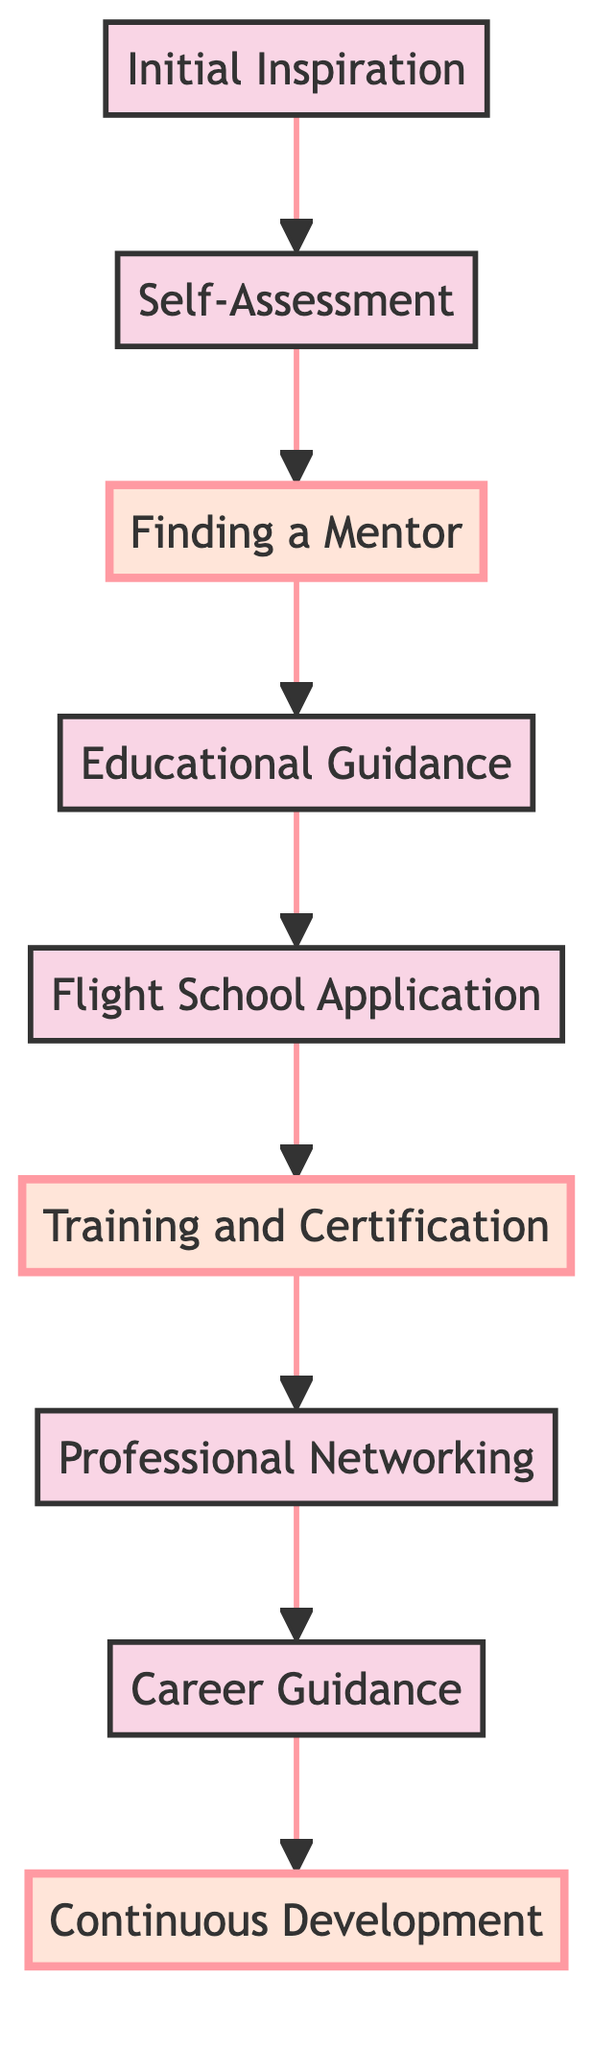What's the first step in the mentorship pathway? The diagram indicates that the first step is "Initial Inspiration," which represents the exposure to pioneering female pilots.
Answer: Initial Inspiration How many nodes are in the diagram? By counting each distinct step as represented in the diagram, there are a total of nine nodes representing various parts of the mentorship pathway.
Answer: 9 What comes after "Finding a Mentor"? Following the node "Finding a Mentor," the next step in the flow is "Educational Guidance," which suggests the move towards receiving advice on suitable aviation programs.
Answer: Educational Guidance Which step focuses on networking within the aviation industry? The diagram identifies "Professional Networking" as the step specifically aimed at building connections within the aviation industry.
Answer: Professional Networking What is the last step in the mentorship pathway? The terminal step in the diagram is "Continuous Development," which reflects the ongoing learning and specialization to enhance skills as a pilot.
Answer: Continuous Development Which two steps are highlighted in the diagram? The highlighted steps are "Finding a Mentor" and "Training and Certification," indicating their importance in the mentorship pathway.
Answer: Finding a Mentor, Training and Certification What does "Career Guidance" entail according to the diagram? The node "Career Guidance" suggests it involves navigating job opportunities and interview processes with support from a mentor, indicating its focus on transitioning to professional roles.
Answer: Navigating job opportunities Is "Self-Assessment" before or after "Initial Inspiration"? The step "Self-Assessment" directly follows "Initial Inspiration" in the flow, signifying a progression from inspiration to personal evaluation.
Answer: After What role does "Educational Guidance" play in the pathway? This step supports aspiring pilots by providing advice on suitable programs and scholarships, leading directly to the application phase for flight school.
Answer: Provides advice on programs and scholarships 